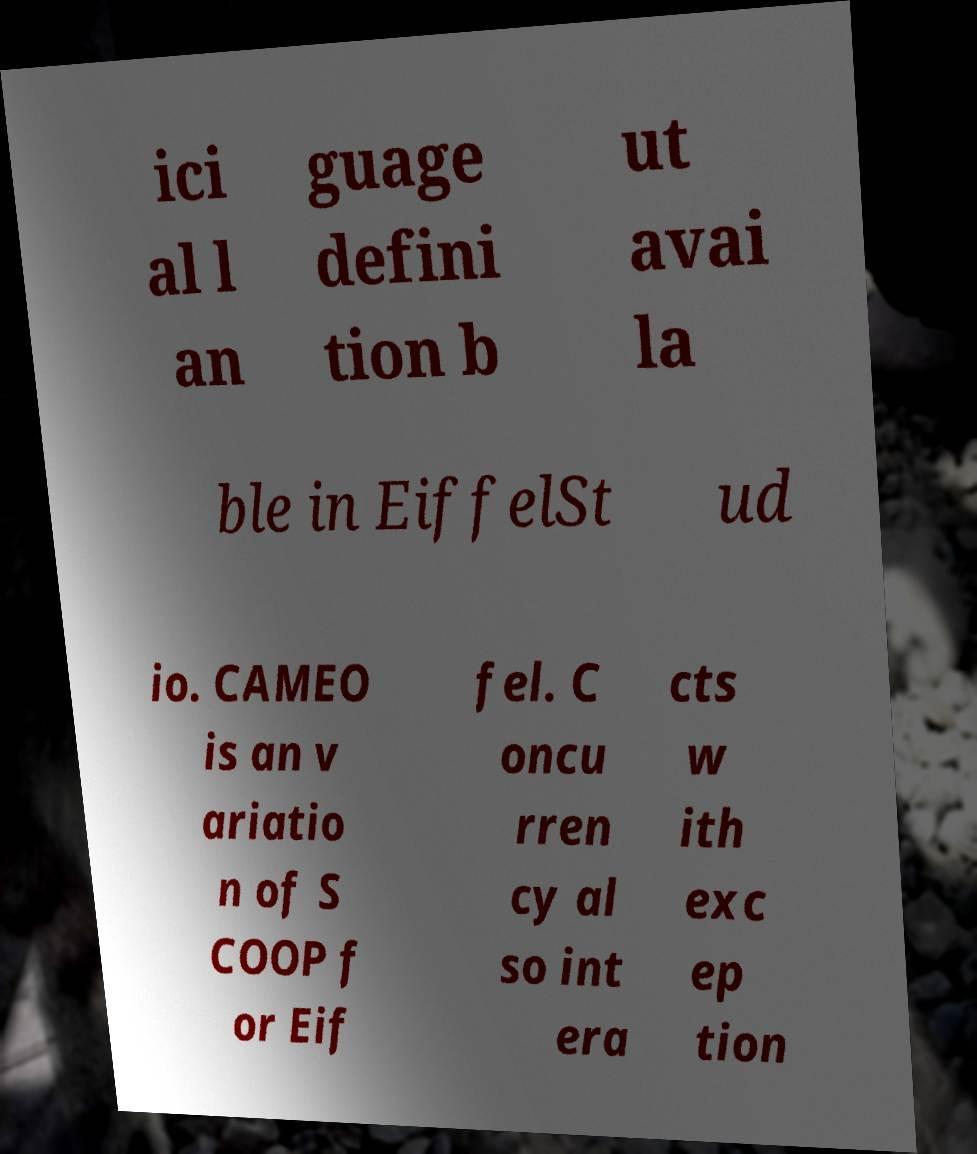Could you assist in decoding the text presented in this image and type it out clearly? ici al l an guage defini tion b ut avai la ble in EiffelSt ud io. CAMEO is an v ariatio n of S COOP f or Eif fel. C oncu rren cy al so int era cts w ith exc ep tion 